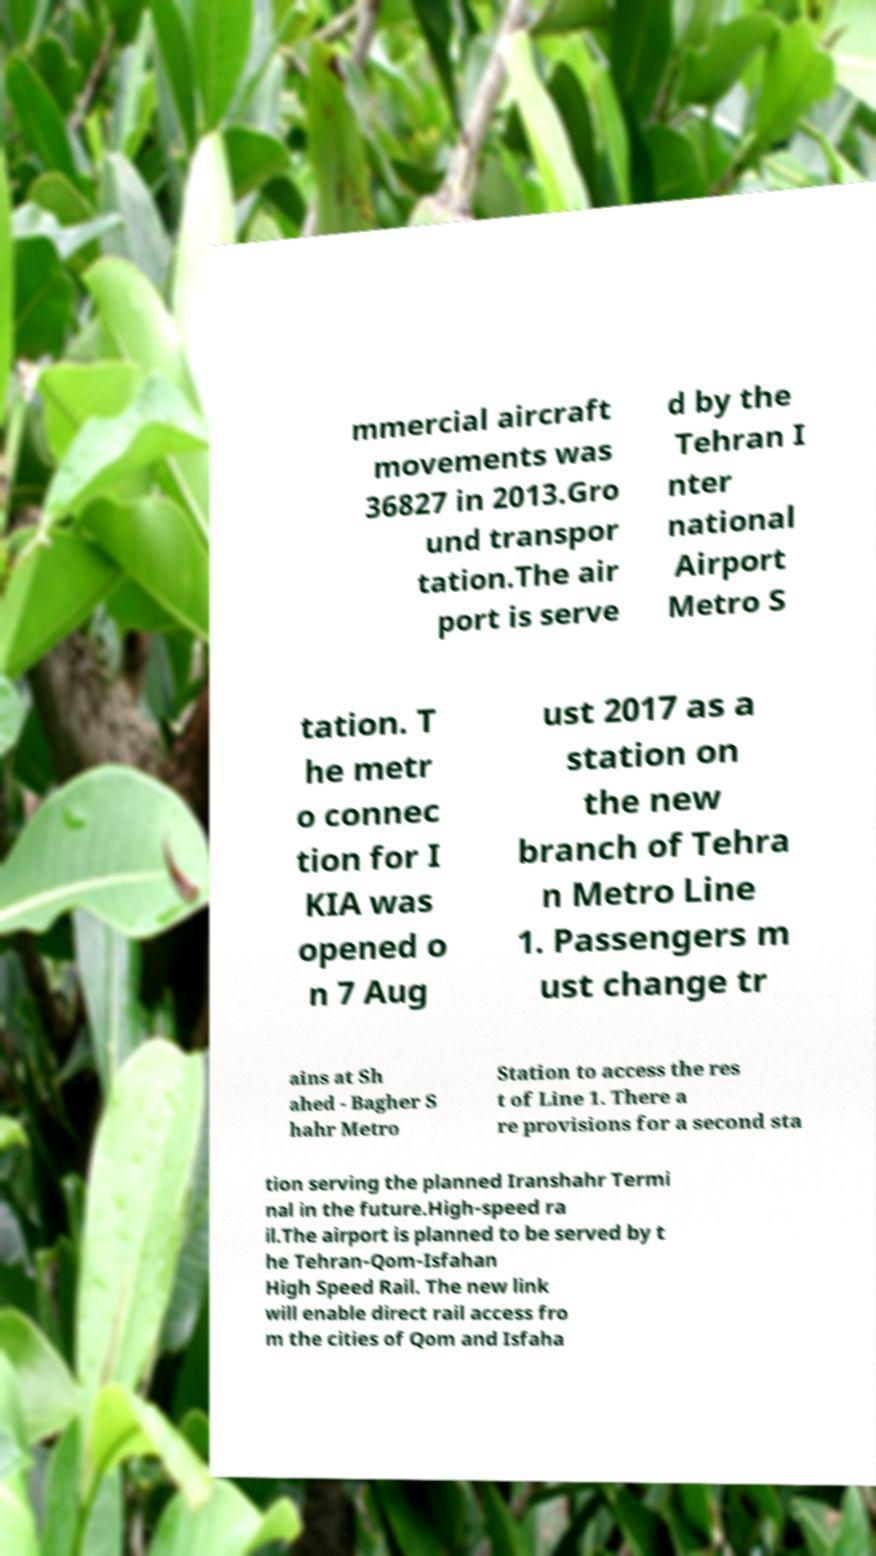Please read and relay the text visible in this image. What does it say? mmercial aircraft movements was 36827 in 2013.Gro und transpor tation.The air port is serve d by the Tehran I nter national Airport Metro S tation. T he metr o connec tion for I KIA was opened o n 7 Aug ust 2017 as a station on the new branch of Tehra n Metro Line 1. Passengers m ust change tr ains at Sh ahed - Bagher S hahr Metro Station to access the res t of Line 1. There a re provisions for a second sta tion serving the planned Iranshahr Termi nal in the future.High-speed ra il.The airport is planned to be served by t he Tehran-Qom-Isfahan High Speed Rail. The new link will enable direct rail access fro m the cities of Qom and Isfaha 